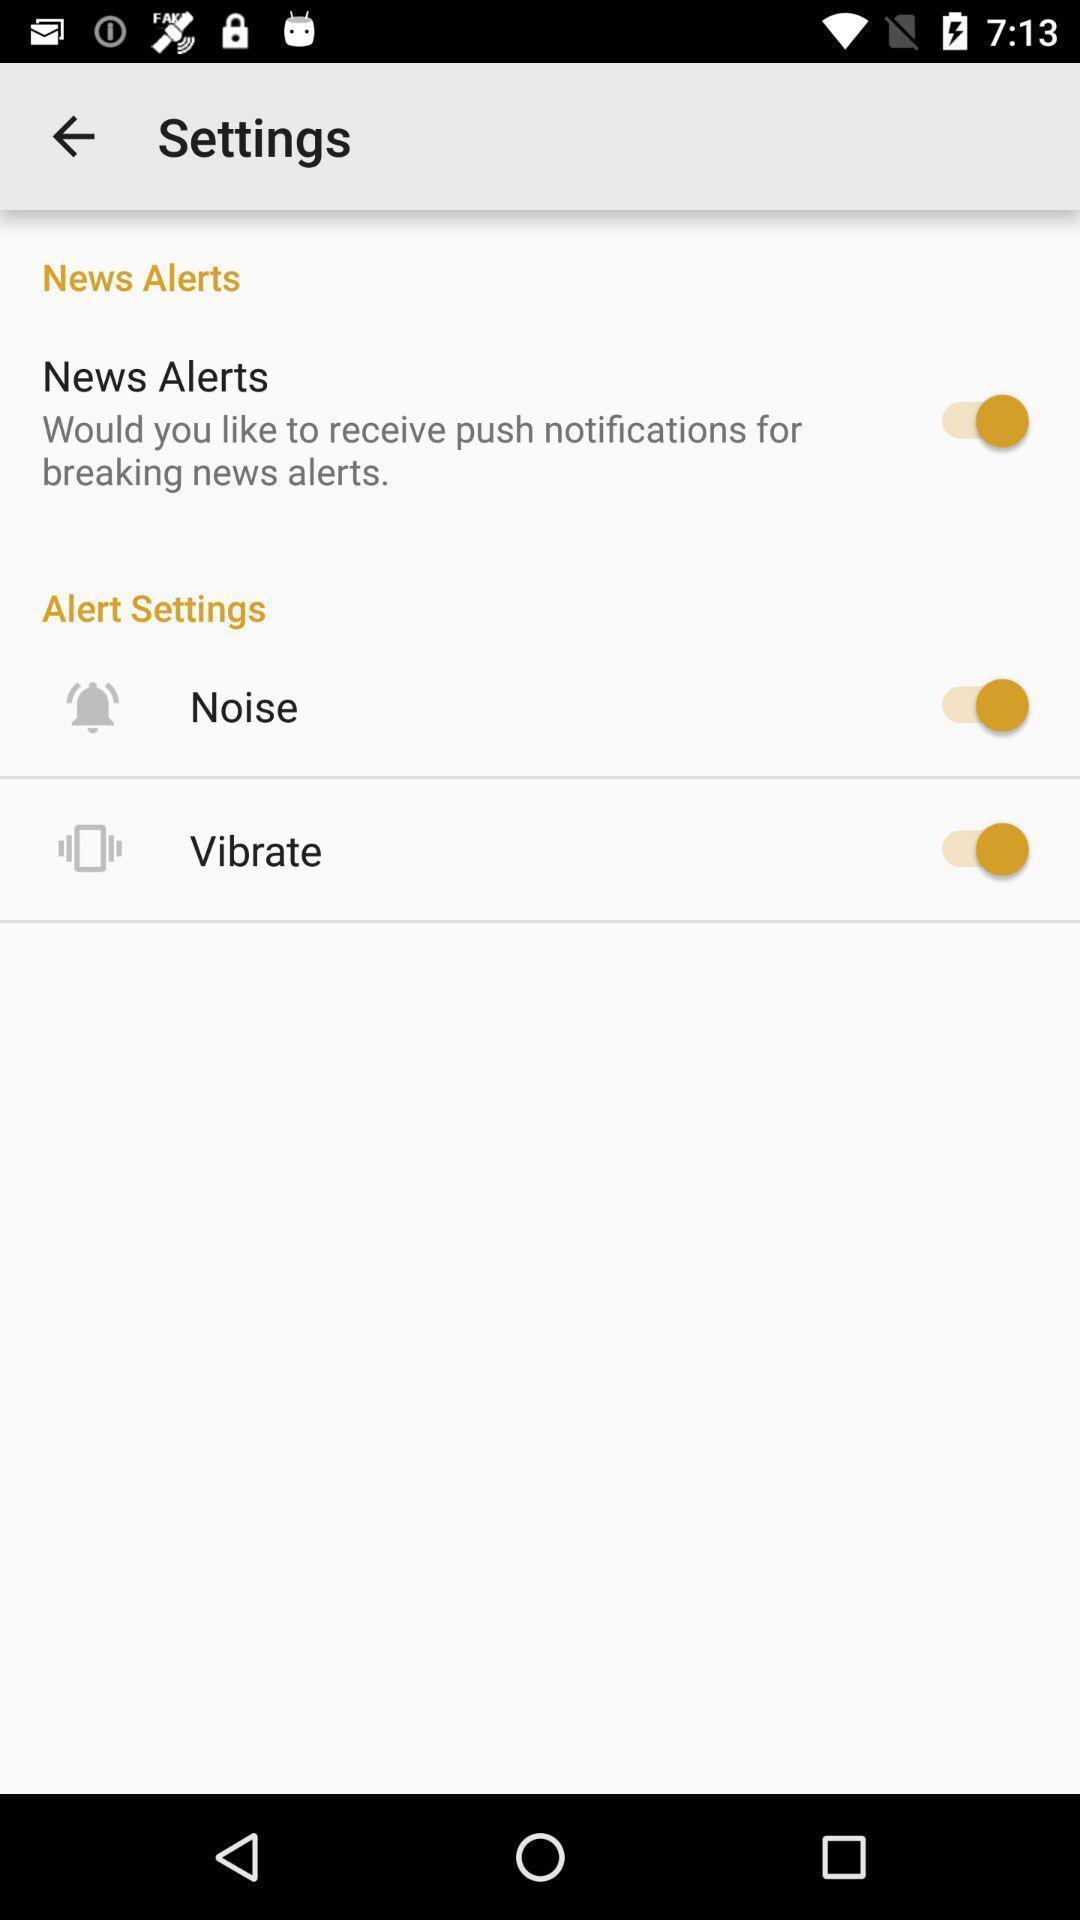Explain the elements present in this screenshot. Page showing different setting options for the news app. 